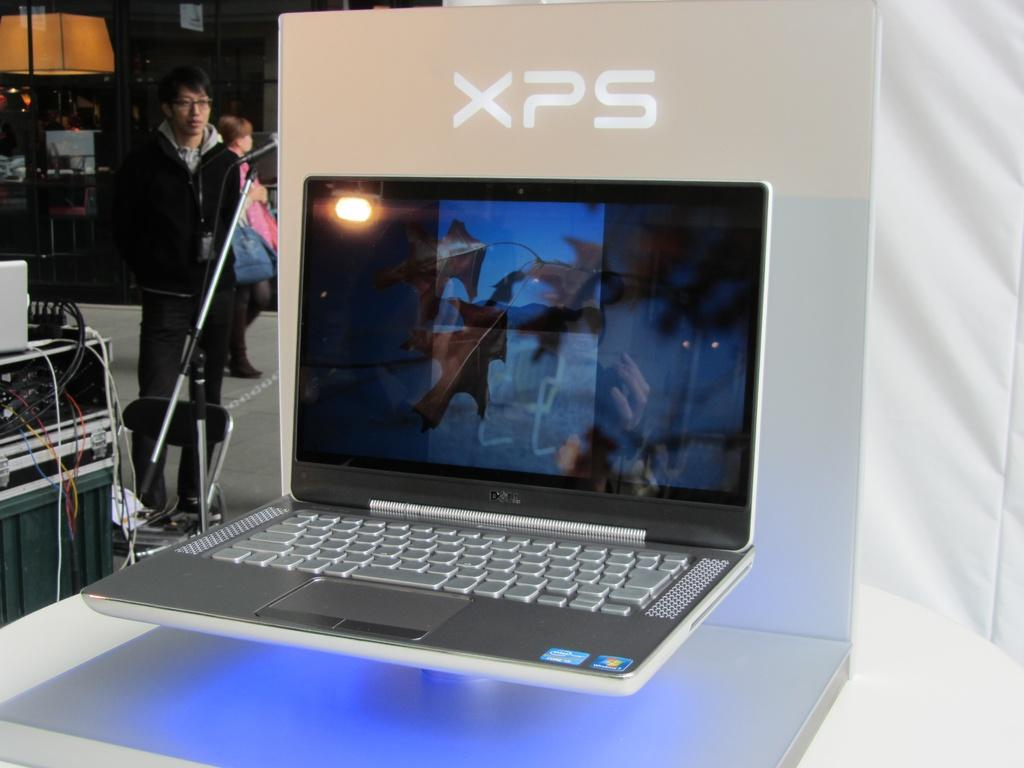<image>
Give a short and clear explanation of the subsequent image. A thin, silver, XPS laptop is on display with a blue light underneath it. 